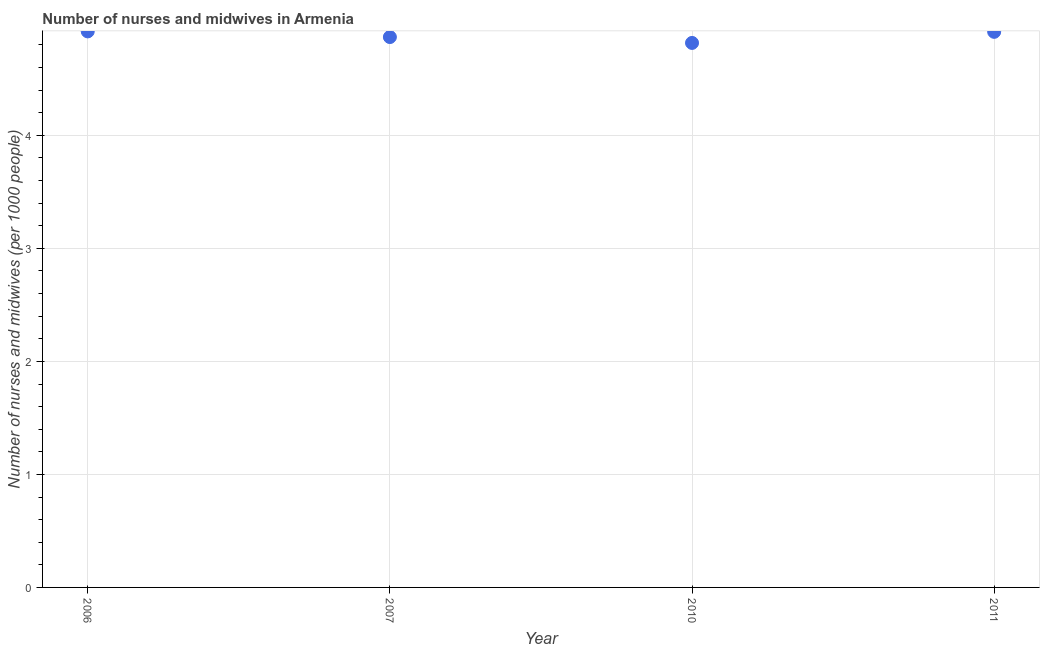What is the number of nurses and midwives in 2007?
Your response must be concise. 4.87. Across all years, what is the maximum number of nurses and midwives?
Offer a very short reply. 4.92. Across all years, what is the minimum number of nurses and midwives?
Ensure brevity in your answer.  4.82. What is the sum of the number of nurses and midwives?
Give a very brief answer. 19.52. What is the difference between the number of nurses and midwives in 2006 and 2007?
Offer a terse response. 0.05. What is the average number of nurses and midwives per year?
Make the answer very short. 4.88. What is the median number of nurses and midwives?
Your answer should be very brief. 4.89. In how many years, is the number of nurses and midwives greater than 2.2 ?
Offer a terse response. 4. What is the ratio of the number of nurses and midwives in 2006 to that in 2007?
Provide a short and direct response. 1.01. Is the number of nurses and midwives in 2010 less than that in 2011?
Give a very brief answer. Yes. What is the difference between the highest and the second highest number of nurses and midwives?
Your answer should be compact. 0. Is the sum of the number of nurses and midwives in 2006 and 2010 greater than the maximum number of nurses and midwives across all years?
Keep it short and to the point. Yes. What is the difference between the highest and the lowest number of nurses and midwives?
Your answer should be very brief. 0.1. In how many years, is the number of nurses and midwives greater than the average number of nurses and midwives taken over all years?
Your response must be concise. 2. How many years are there in the graph?
Ensure brevity in your answer.  4. Does the graph contain any zero values?
Provide a succinct answer. No. Does the graph contain grids?
Keep it short and to the point. Yes. What is the title of the graph?
Ensure brevity in your answer.  Number of nurses and midwives in Armenia. What is the label or title of the Y-axis?
Provide a succinct answer. Number of nurses and midwives (per 1000 people). What is the Number of nurses and midwives (per 1000 people) in 2006?
Provide a short and direct response. 4.92. What is the Number of nurses and midwives (per 1000 people) in 2007?
Provide a succinct answer. 4.87. What is the Number of nurses and midwives (per 1000 people) in 2010?
Give a very brief answer. 4.82. What is the Number of nurses and midwives (per 1000 people) in 2011?
Offer a terse response. 4.92. What is the difference between the Number of nurses and midwives (per 1000 people) in 2006 and 2007?
Keep it short and to the point. 0.05. What is the difference between the Number of nurses and midwives (per 1000 people) in 2006 and 2010?
Your answer should be very brief. 0.1. What is the difference between the Number of nurses and midwives (per 1000 people) in 2006 and 2011?
Ensure brevity in your answer.  0. What is the difference between the Number of nurses and midwives (per 1000 people) in 2007 and 2010?
Your response must be concise. 0.05. What is the difference between the Number of nurses and midwives (per 1000 people) in 2007 and 2011?
Your response must be concise. -0.05. What is the difference between the Number of nurses and midwives (per 1000 people) in 2010 and 2011?
Make the answer very short. -0.1. What is the ratio of the Number of nurses and midwives (per 1000 people) in 2006 to that in 2011?
Your answer should be compact. 1. What is the ratio of the Number of nurses and midwives (per 1000 people) in 2007 to that in 2010?
Keep it short and to the point. 1.01. What is the ratio of the Number of nurses and midwives (per 1000 people) in 2007 to that in 2011?
Give a very brief answer. 0.99. 